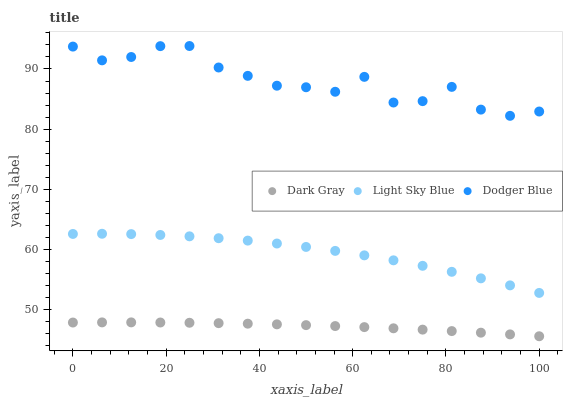Does Dark Gray have the minimum area under the curve?
Answer yes or no. Yes. Does Dodger Blue have the maximum area under the curve?
Answer yes or no. Yes. Does Light Sky Blue have the minimum area under the curve?
Answer yes or no. No. Does Light Sky Blue have the maximum area under the curve?
Answer yes or no. No. Is Dark Gray the smoothest?
Answer yes or no. Yes. Is Dodger Blue the roughest?
Answer yes or no. Yes. Is Light Sky Blue the smoothest?
Answer yes or no. No. Is Light Sky Blue the roughest?
Answer yes or no. No. Does Dark Gray have the lowest value?
Answer yes or no. Yes. Does Light Sky Blue have the lowest value?
Answer yes or no. No. Does Dodger Blue have the highest value?
Answer yes or no. Yes. Does Light Sky Blue have the highest value?
Answer yes or no. No. Is Dark Gray less than Dodger Blue?
Answer yes or no. Yes. Is Light Sky Blue greater than Dark Gray?
Answer yes or no. Yes. Does Dark Gray intersect Dodger Blue?
Answer yes or no. No. 